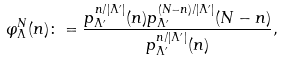<formula> <loc_0><loc_0><loc_500><loc_500>\varphi _ { \Lambda } ^ { N } ( n ) \colon = \frac { p _ { \Lambda ^ { \prime } } ^ { n / | \Lambda ^ { \prime } | } ( n ) p _ { \Lambda ^ { \prime } } ^ { ( N - n ) / | \Lambda ^ { \prime } | } ( N - n ) } { p _ { \Lambda ^ { \prime } } ^ { n / | \Lambda ^ { \prime } | } ( n ) } ,</formula> 